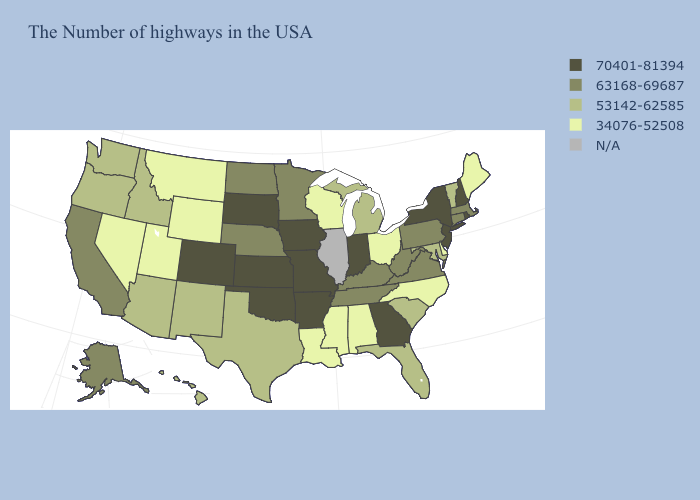What is the highest value in states that border Oregon?
Short answer required. 63168-69687. Among the states that border Virginia , does Tennessee have the highest value?
Be succinct. Yes. Among the states that border Arkansas , which have the lowest value?
Be succinct. Mississippi, Louisiana. What is the value of South Carolina?
Answer briefly. 53142-62585. Name the states that have a value in the range 53142-62585?
Concise answer only. Vermont, Maryland, South Carolina, Florida, Michigan, Texas, New Mexico, Arizona, Idaho, Washington, Oregon, Hawaii. What is the lowest value in the West?
Short answer required. 34076-52508. What is the value of Pennsylvania?
Keep it brief. 63168-69687. Which states have the highest value in the USA?
Write a very short answer. Rhode Island, New Hampshire, New York, New Jersey, Georgia, Indiana, Missouri, Arkansas, Iowa, Kansas, Oklahoma, South Dakota, Colorado. Does the map have missing data?
Quick response, please. Yes. What is the value of Delaware?
Write a very short answer. 34076-52508. Does Alabama have the lowest value in the USA?
Keep it brief. Yes. What is the value of Minnesota?
Concise answer only. 63168-69687. What is the value of Missouri?
Answer briefly. 70401-81394. Among the states that border Florida , which have the lowest value?
Write a very short answer. Alabama. 